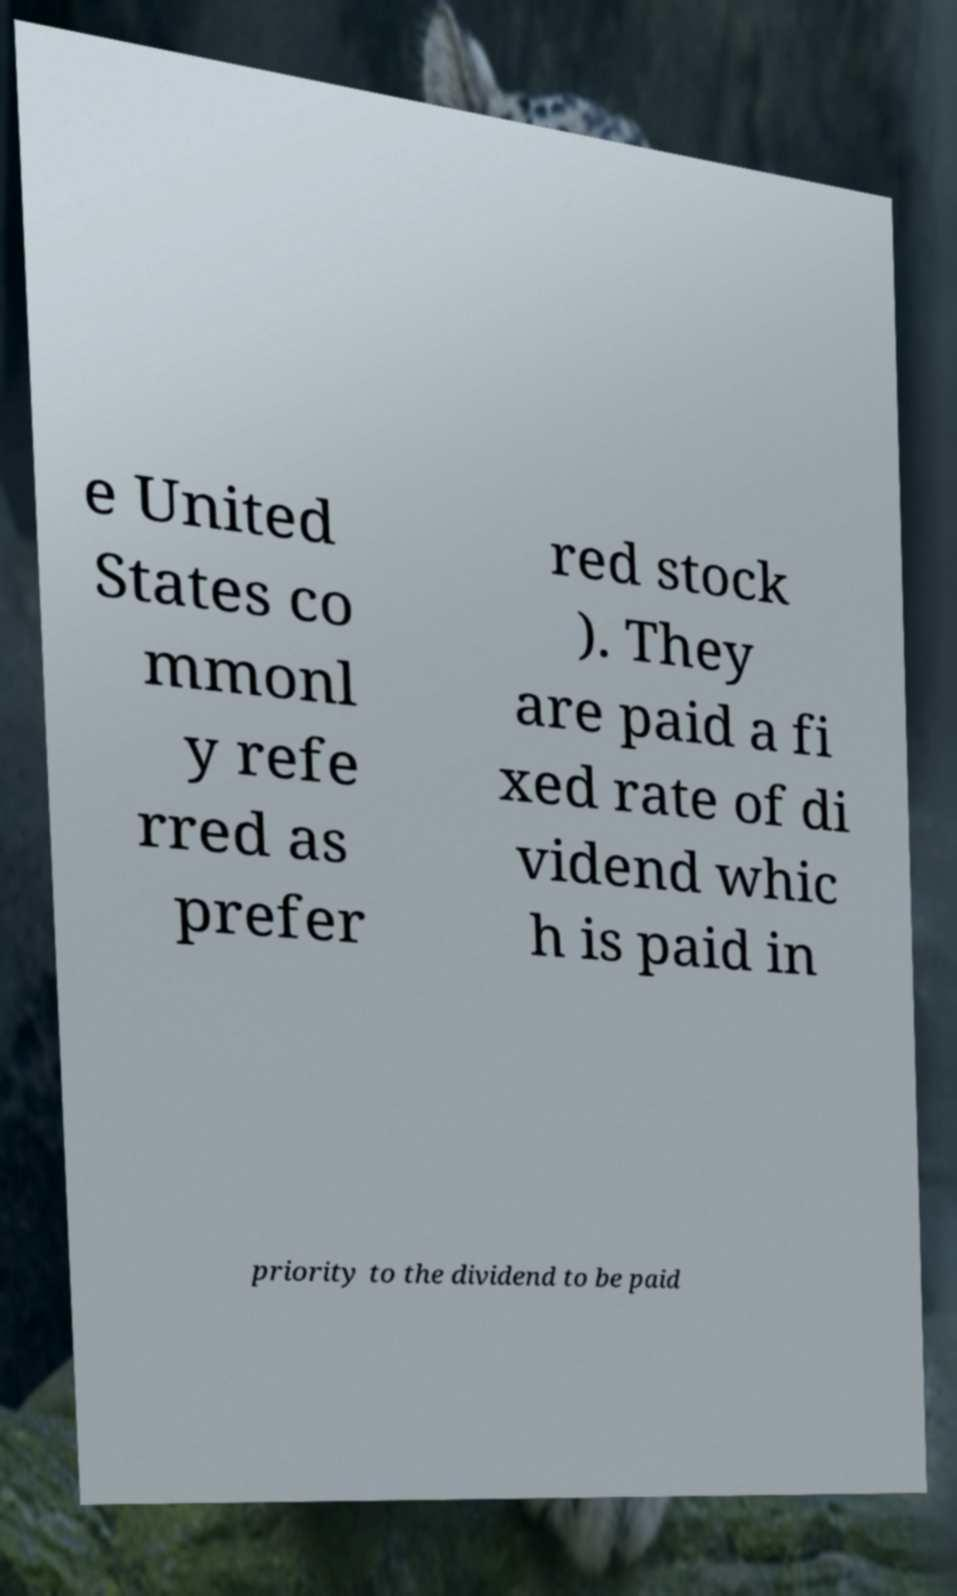Could you assist in decoding the text presented in this image and type it out clearly? e United States co mmonl y refe rred as prefer red stock ). They are paid a fi xed rate of di vidend whic h is paid in priority to the dividend to be paid 